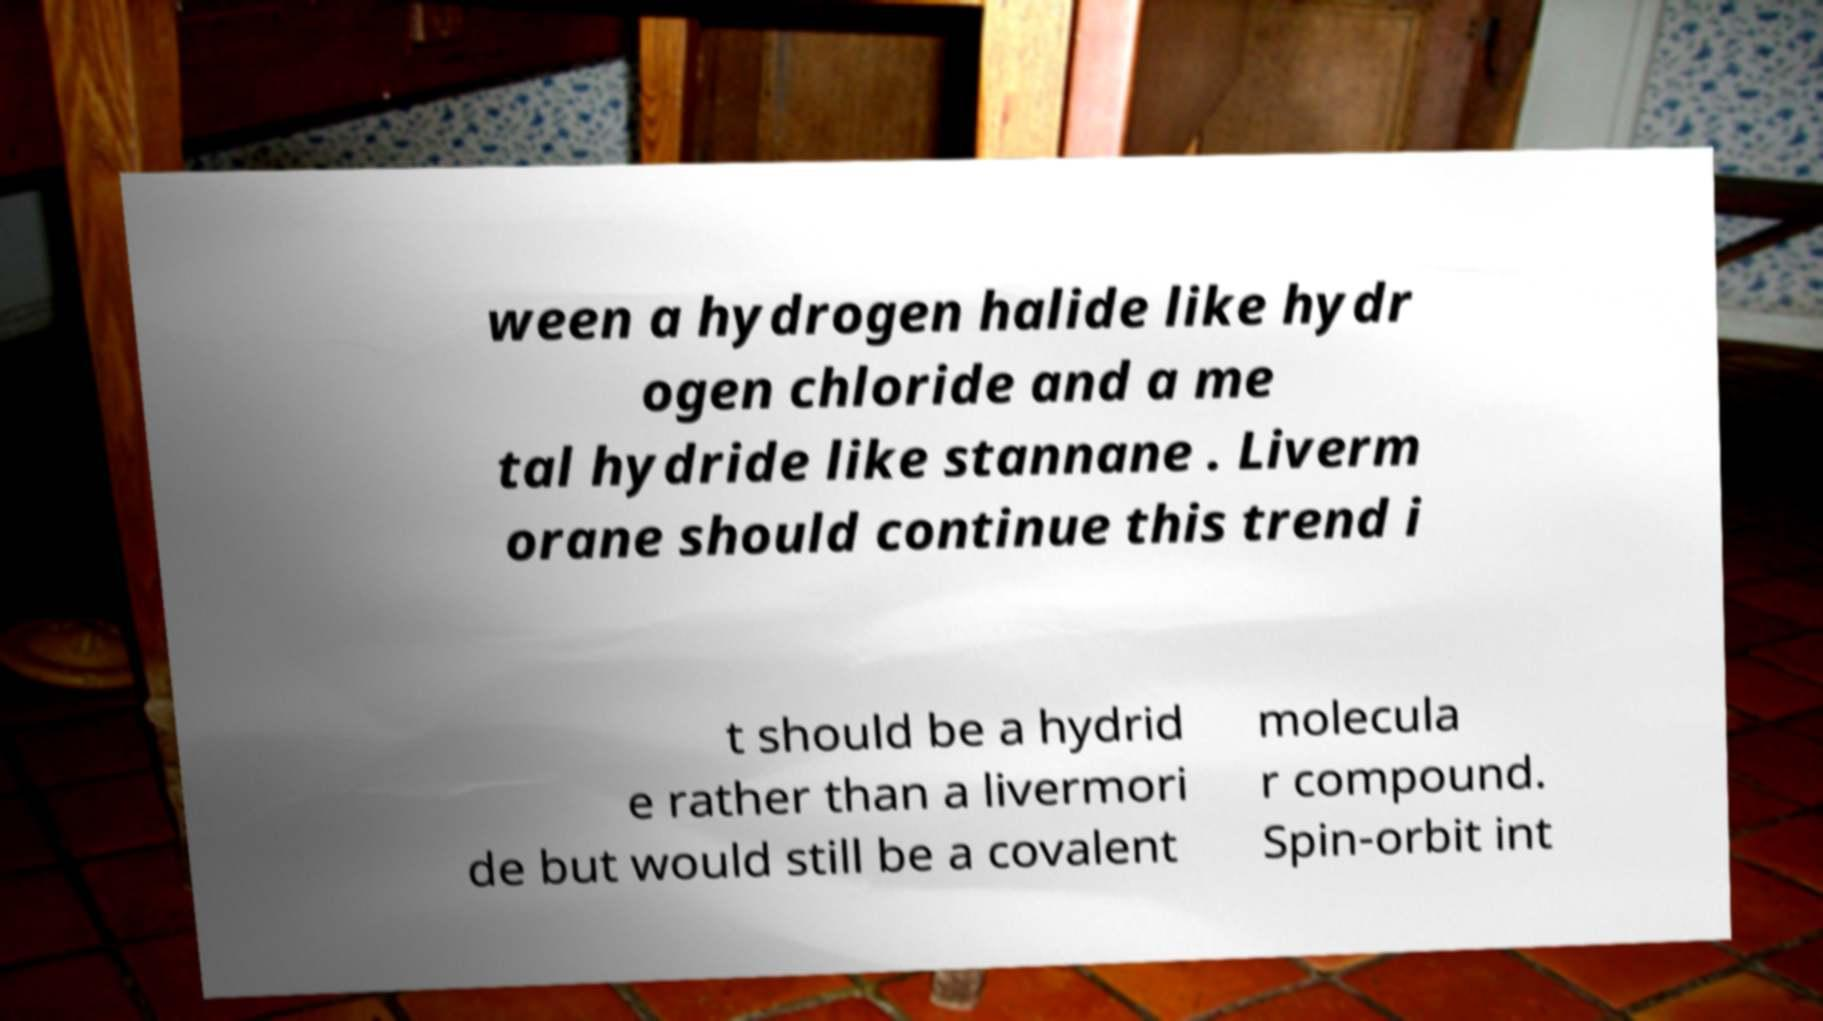Please read and relay the text visible in this image. What does it say? ween a hydrogen halide like hydr ogen chloride and a me tal hydride like stannane . Liverm orane should continue this trend i t should be a hydrid e rather than a livermori de but would still be a covalent molecula r compound. Spin-orbit int 